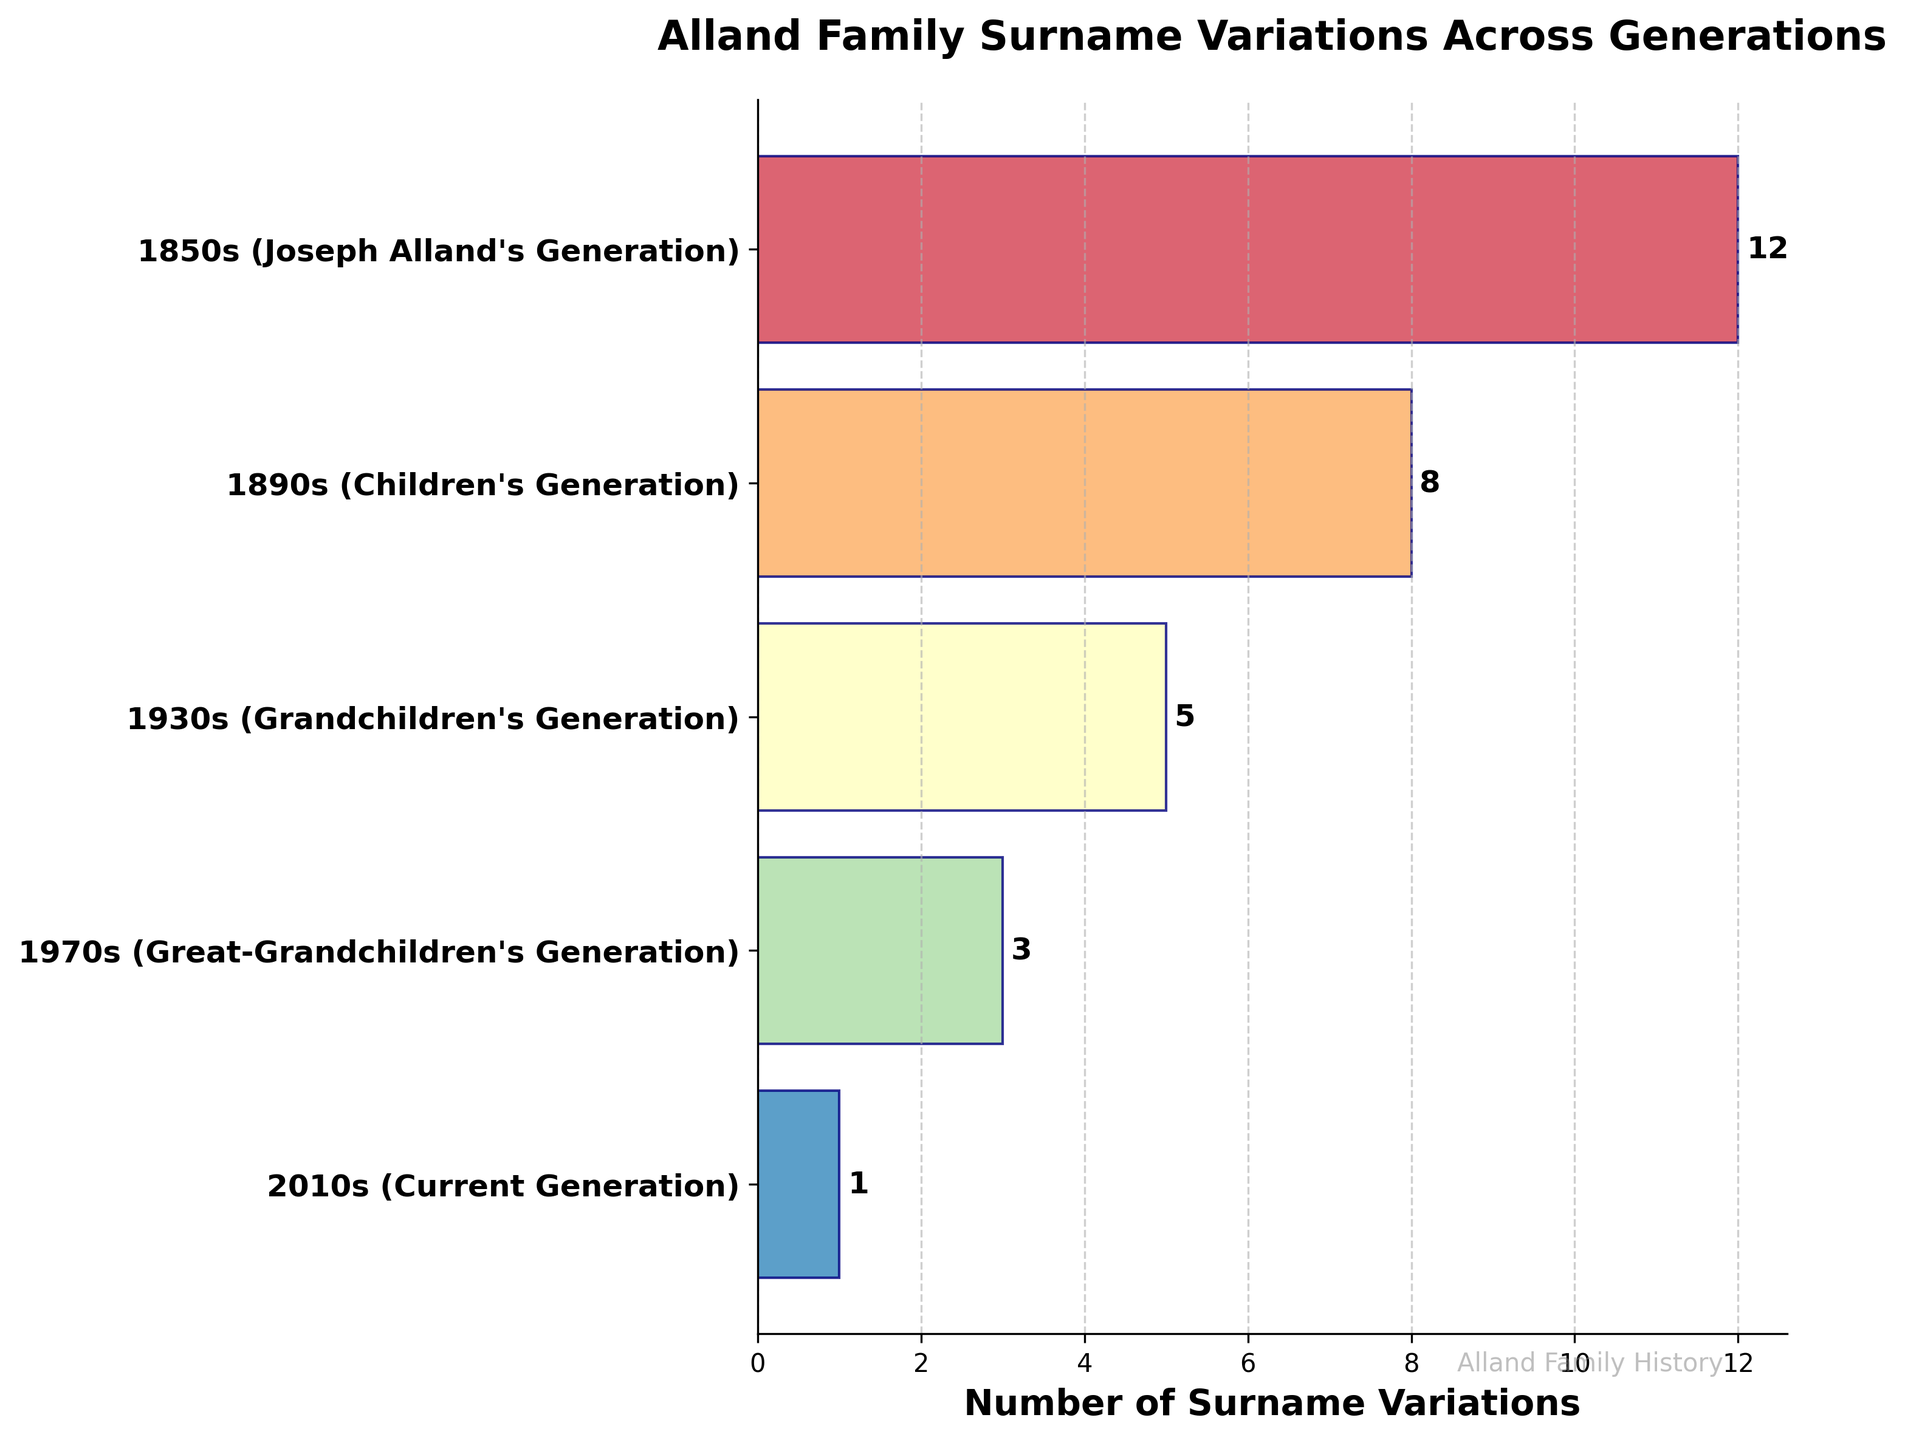What is the title of the chart? At the top of the chart, there is a large, bold label in readable font specifying the title.
Answer: Alland Family Surname Variations Across Generations How many generations are included in the chart? The chart shows various stages on the y-axis, each representing a generation's time period. Counting these stages will give the total number of generations depicted.
Answer: 5 Which generation had the highest number of surname variations? The bar with the longest length on the horizontal axis represents the highest number of surname variations.
Answer: Joseph Alland's Generation How many surname variations were there in the 1930s, and how does it compare to the 1970s? Locate the lengths of the bars corresponding to 1930s and 1970s, then compare their values shown in figures.
Answer: 1930s: 5, 1970s: 3. The 1930s had 2 more variations than the 1970s What is the total number of surname variations across all generations combined? Add the values corresponding to all the bars representing each generation.
Answer: 12 + 8 + 5 + 3 + 1 = 29 By how many variations did the number of surnames decrease from Joseph Alland's generation to the current generation? Subtract the number of surname variations in the current generation from Joseph Alland's generation.
Answer: 12 - 1 = 11 What is the average number of surname variations across all generations? Calculate the total sum of surname variations across all generations and then divide it by the number of generations.
Answer: (12 + 8 + 5 + 3 + 1) / 5 = 5 Which generation had the least number of surname variations? Identify the shortest bar on the chart, which corresponds to the generation with the least number of surname variations.
Answer: Current Generation Compare the number of surname variations between Joseph Alland's generation and his grandchildren's generation. Which is greater? Find the values corresponding to Joseph Alland's generation and his grandchildren's generation, then compare these values.
Answer: Joseph Alland's generation (12) is greater than his grandchildren's generation (5) What is the difference in the number of surname variations between Joseph Alland's generation and his children's generation? Subtract the number of surname variations in the children's generation from Joseph Alland's generation.
Answer: 12 - 8 = 4 